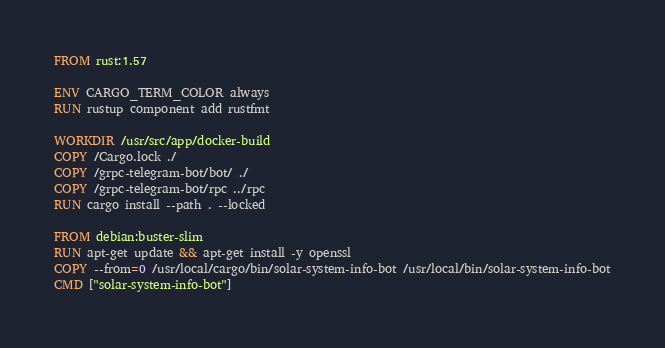<code> <loc_0><loc_0><loc_500><loc_500><_Dockerfile_>FROM rust:1.57

ENV CARGO_TERM_COLOR always
RUN rustup component add rustfmt

WORKDIR /usr/src/app/docker-build
COPY /Cargo.lock ./
COPY /grpc-telegram-bot/bot/ ./
COPY /grpc-telegram-bot/rpc ../rpc
RUN cargo install --path . --locked

FROM debian:buster-slim
RUN apt-get update && apt-get install -y openssl
COPY --from=0 /usr/local/cargo/bin/solar-system-info-bot /usr/local/bin/solar-system-info-bot
CMD ["solar-system-info-bot"]
</code> 